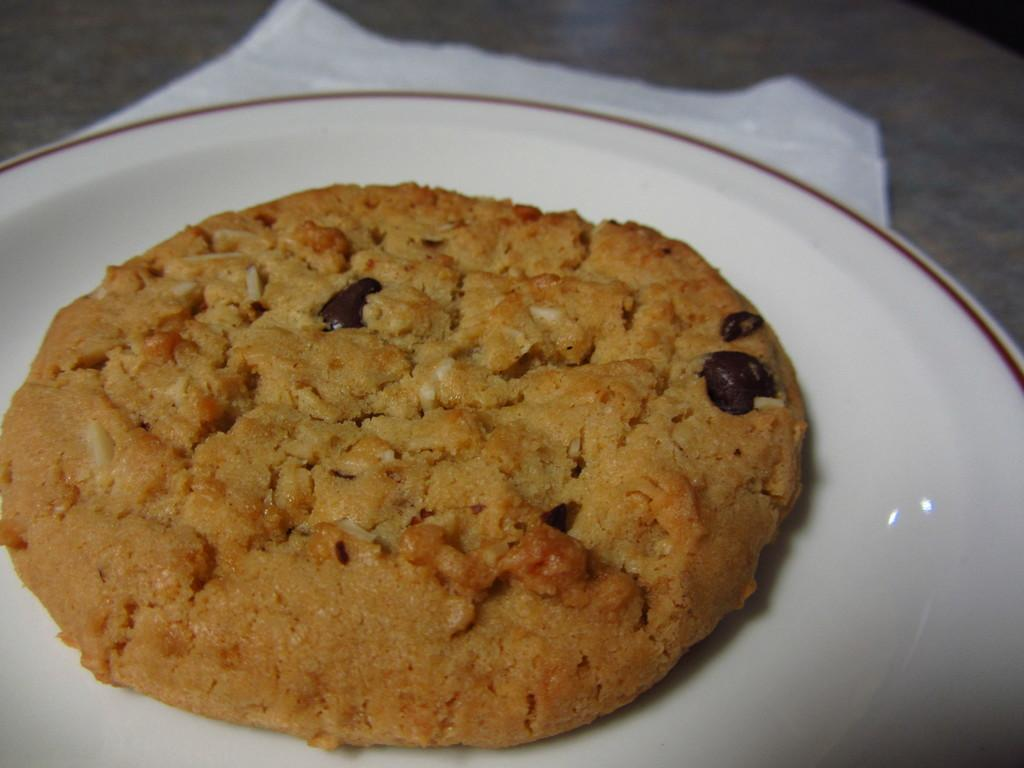What is the main subject of the image? There is a cookie in the image. Where is the cookie located? The cookie is placed on a white plate. What type of advice can be seen written on the cookie in the image? There is no advice written on the cookie in the image; it is just a cookie placed on a white plate. 